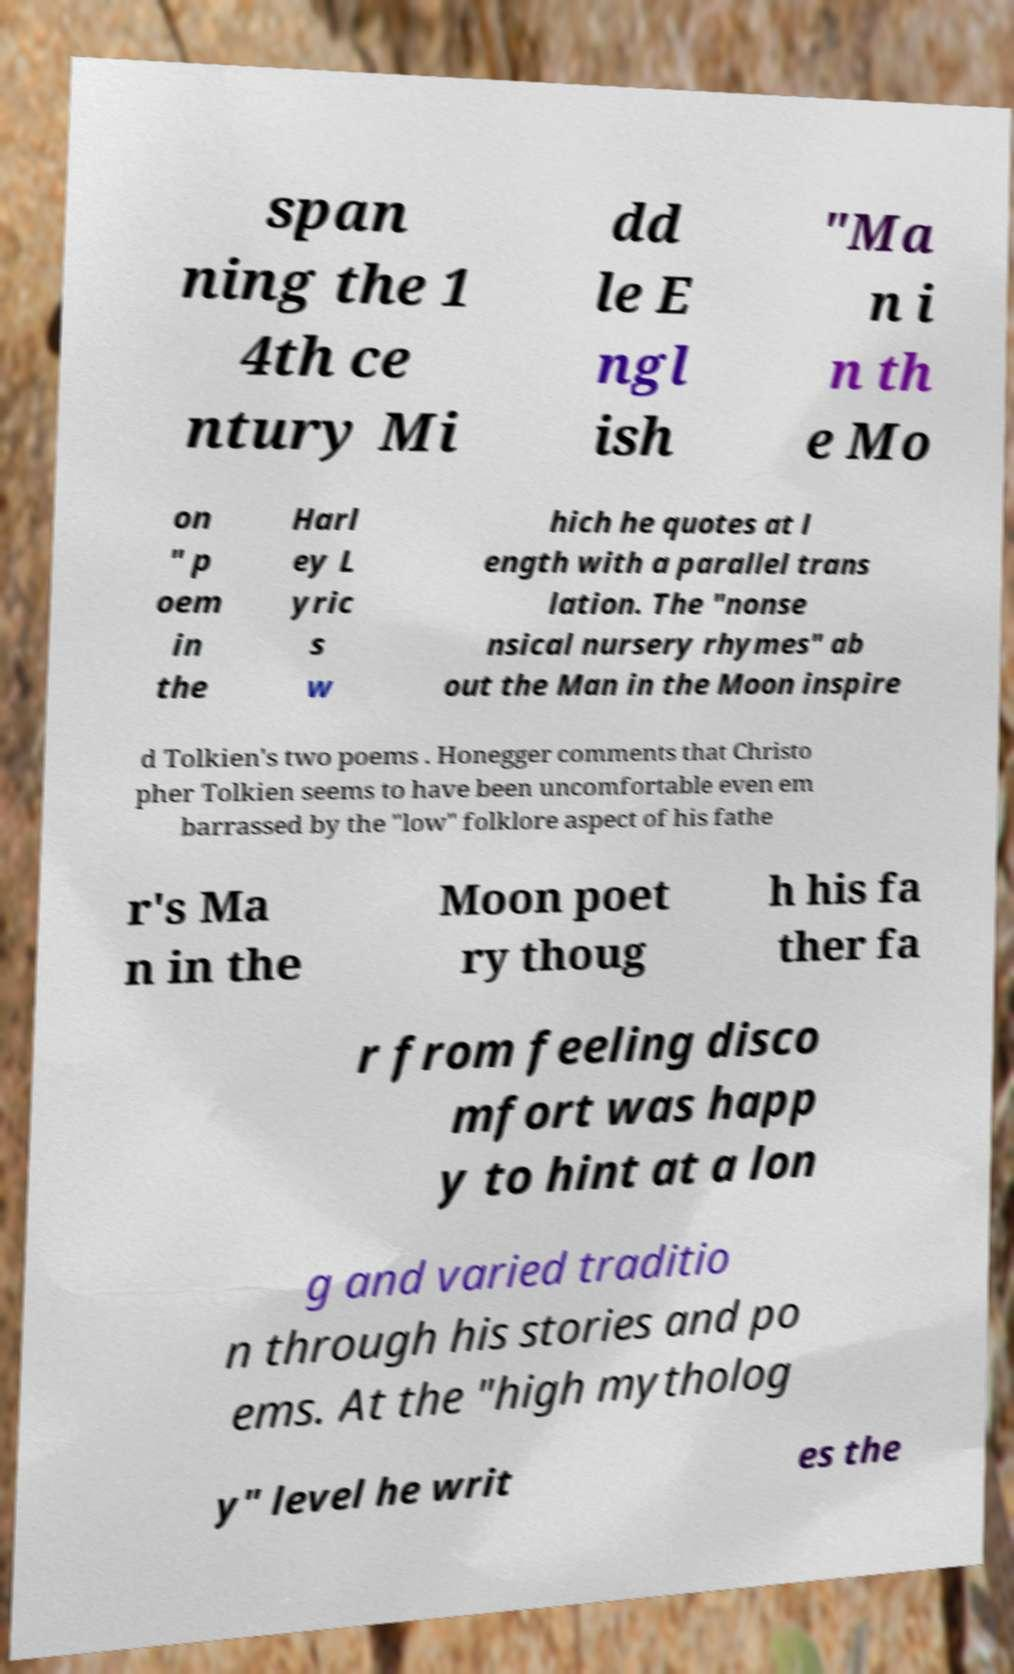Can you accurately transcribe the text from the provided image for me? span ning the 1 4th ce ntury Mi dd le E ngl ish "Ma n i n th e Mo on " p oem in the Harl ey L yric s w hich he quotes at l ength with a parallel trans lation. The "nonse nsical nursery rhymes" ab out the Man in the Moon inspire d Tolkien's two poems . Honegger comments that Christo pher Tolkien seems to have been uncomfortable even em barrassed by the "low" folklore aspect of his fathe r's Ma n in the Moon poet ry thoug h his fa ther fa r from feeling disco mfort was happ y to hint at a lon g and varied traditio n through his stories and po ems. At the "high mytholog y" level he writ es the 